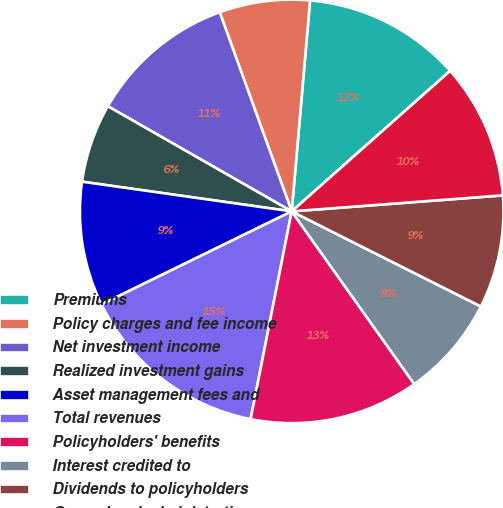<chart> <loc_0><loc_0><loc_500><loc_500><pie_chart><fcel>Premiums<fcel>Policy charges and fee income<fcel>Net investment income<fcel>Realized investment gains<fcel>Asset management fees and<fcel>Total revenues<fcel>Policyholders' benefits<fcel>Interest credited to<fcel>Dividends to policyholders<fcel>General and administrative<nl><fcel>12.07%<fcel>6.9%<fcel>11.21%<fcel>6.03%<fcel>9.48%<fcel>14.65%<fcel>12.93%<fcel>7.76%<fcel>8.62%<fcel>10.34%<nl></chart> 